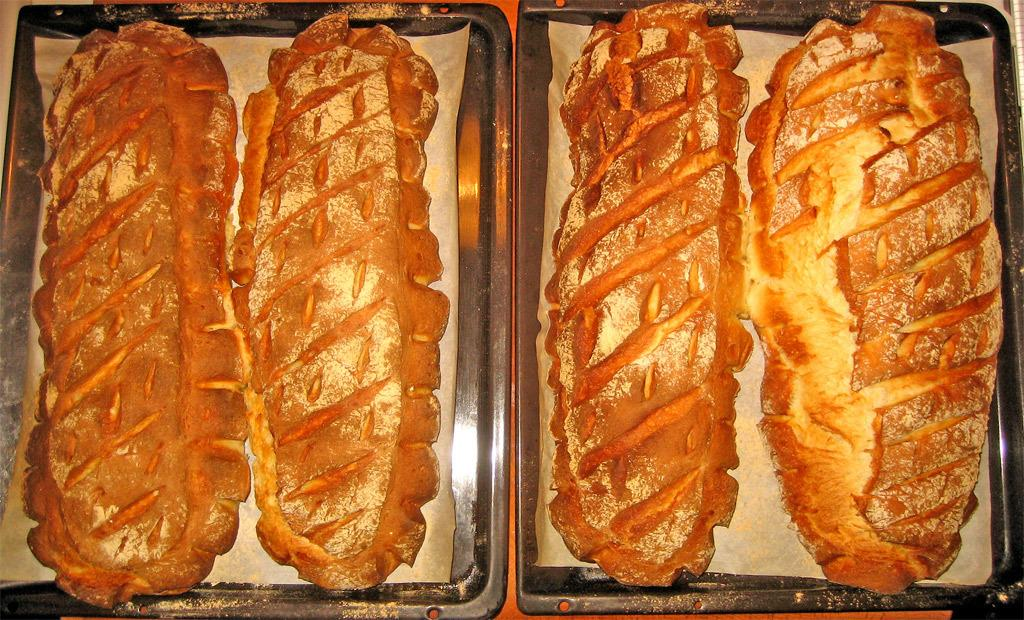How many trays are visible in the image? There are two trays in the image. What can be found on the trays? The trays contain food items. Are there any icicles hanging from the trays in the image? No, there are no icicles present in the image. 